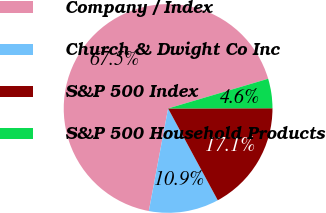Convert chart to OTSL. <chart><loc_0><loc_0><loc_500><loc_500><pie_chart><fcel>Company / Index<fcel>Church & Dwight Co Inc<fcel>S&P 500 Index<fcel>S&P 500 Household Products<nl><fcel>67.45%<fcel>10.85%<fcel>17.14%<fcel>4.56%<nl></chart> 